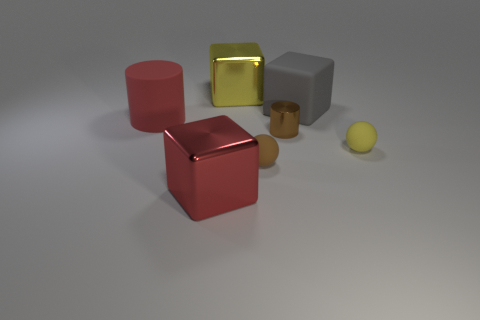Add 1 red matte cylinders. How many objects exist? 8 Subtract all cylinders. How many objects are left? 5 Subtract all red cylinders. Subtract all yellow blocks. How many objects are left? 5 Add 3 tiny shiny cylinders. How many tiny shiny cylinders are left? 4 Add 3 big yellow metal blocks. How many big yellow metal blocks exist? 4 Subtract 0 cyan cylinders. How many objects are left? 7 